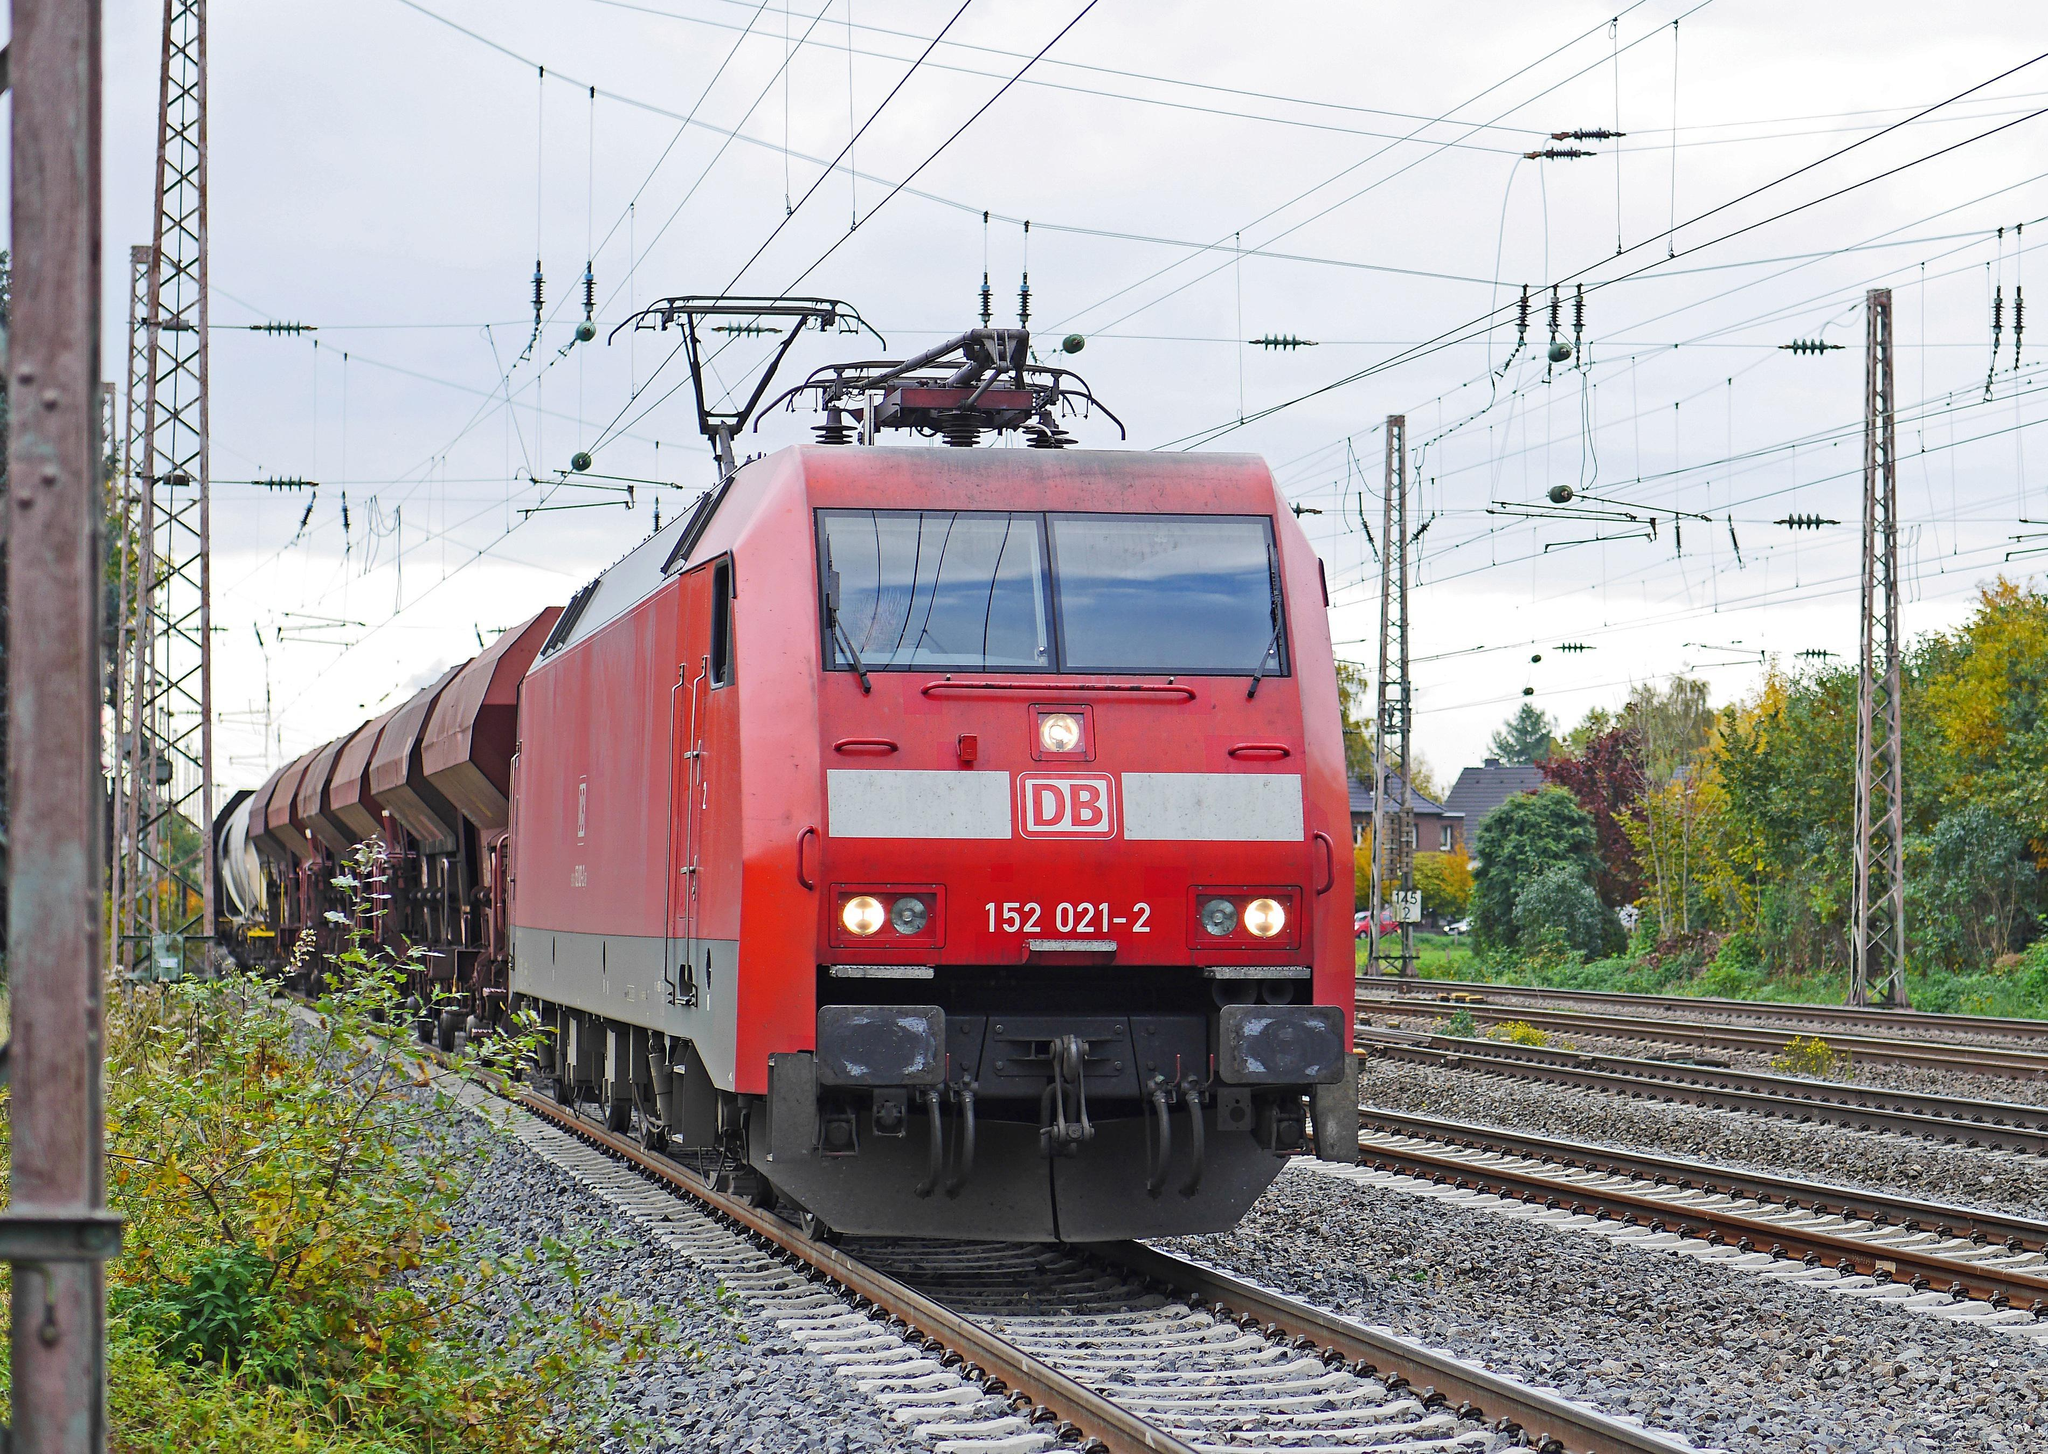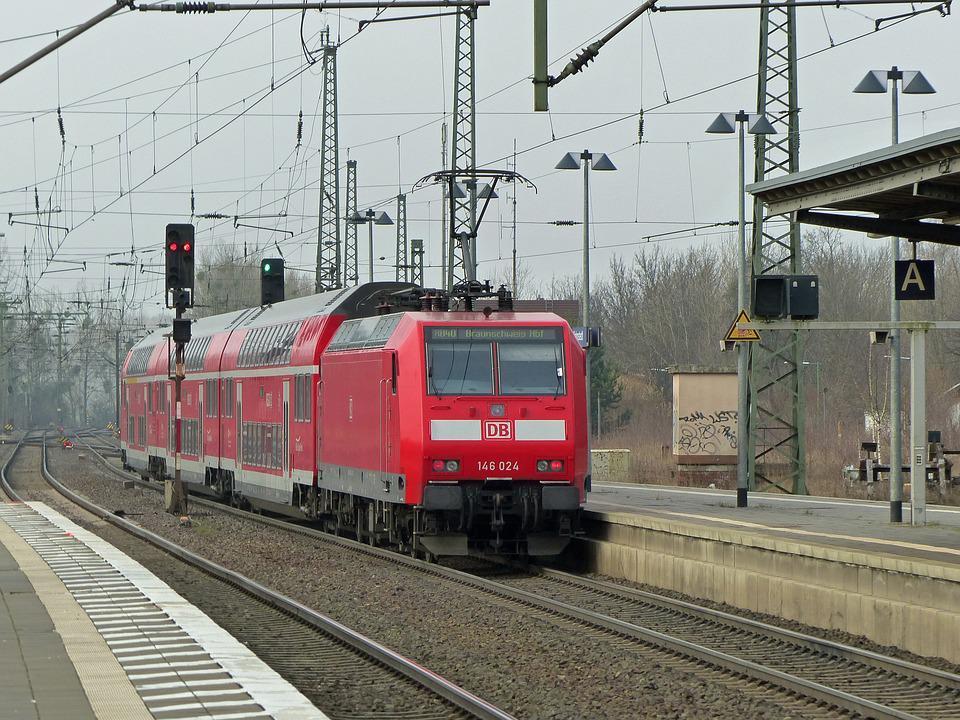The first image is the image on the left, the second image is the image on the right. Evaluate the accuracy of this statement regarding the images: "Each image includes one predominantly red train on a track.". Is it true? Answer yes or no. Yes. The first image is the image on the left, the second image is the image on the right. Evaluate the accuracy of this statement regarding the images: "The train in one of the images is black with red rims.". Is it true? Answer yes or no. No. 